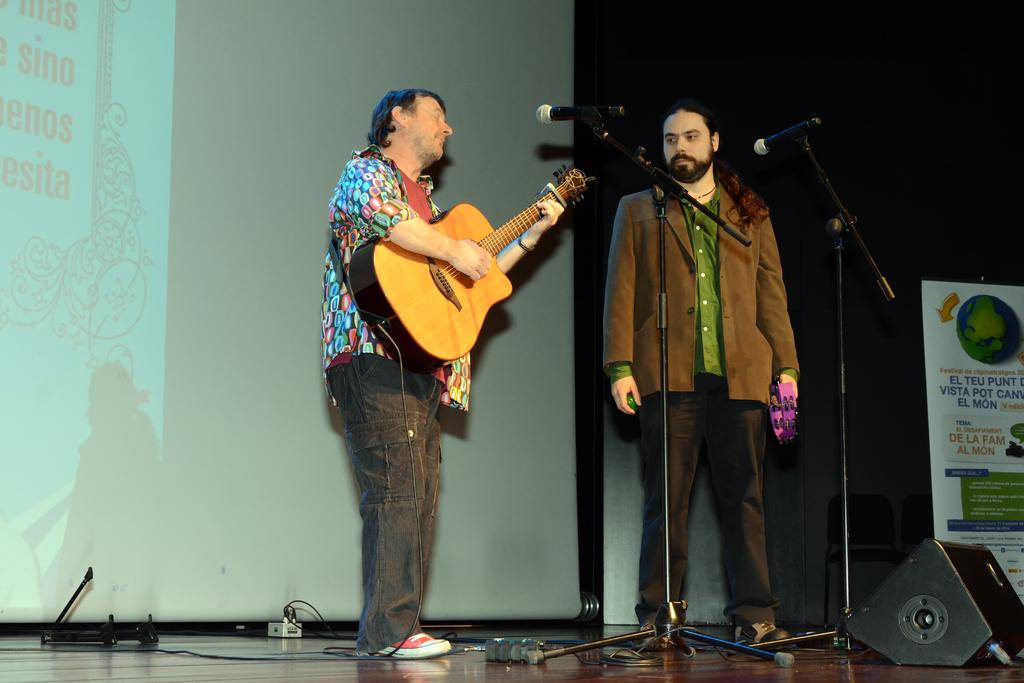What is the man in the image doing? The man is playing a guitar. Where is the man playing the guitar? The man is standing on a street. What object is the man standing in front of? The man is standing in front of a microphone. Is there anyone else in the image besides the man playing the guitar? Yes, there is another person watching the man play guitar. How many eggs does the man have in his pocket in the image? There is no mention of eggs in the image, so it cannot be determined if the man has any eggs in his pocket. 